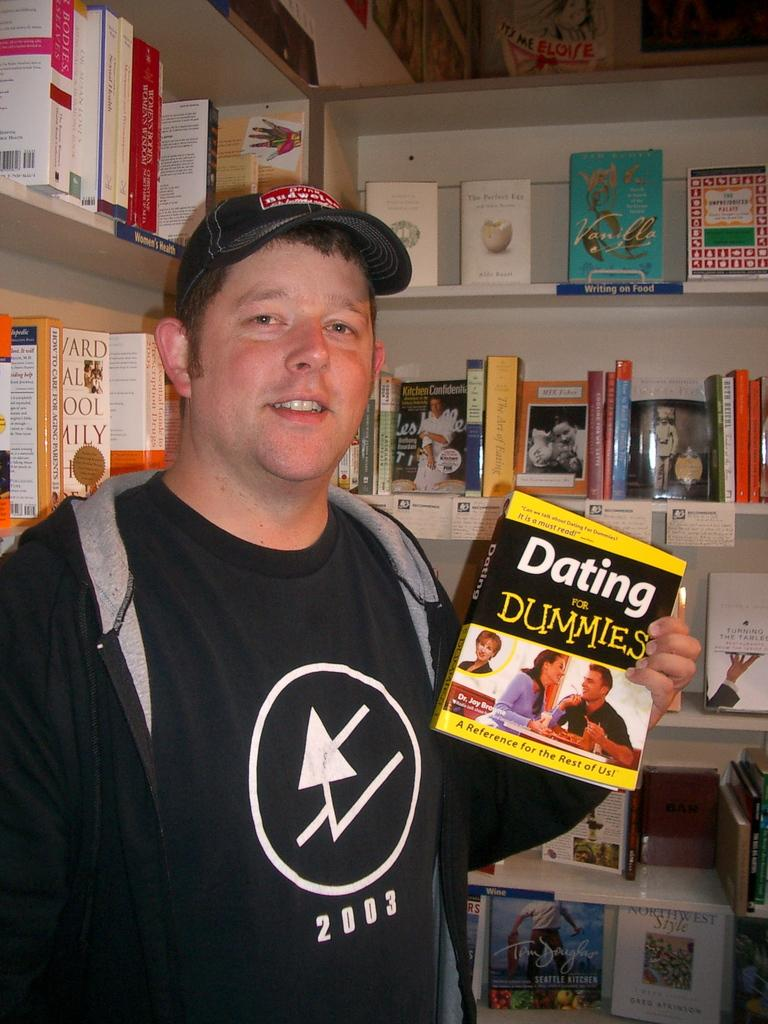<image>
Create a compact narrative representing the image presented. A man holding the book Dating for Dummies in a bookstore. 